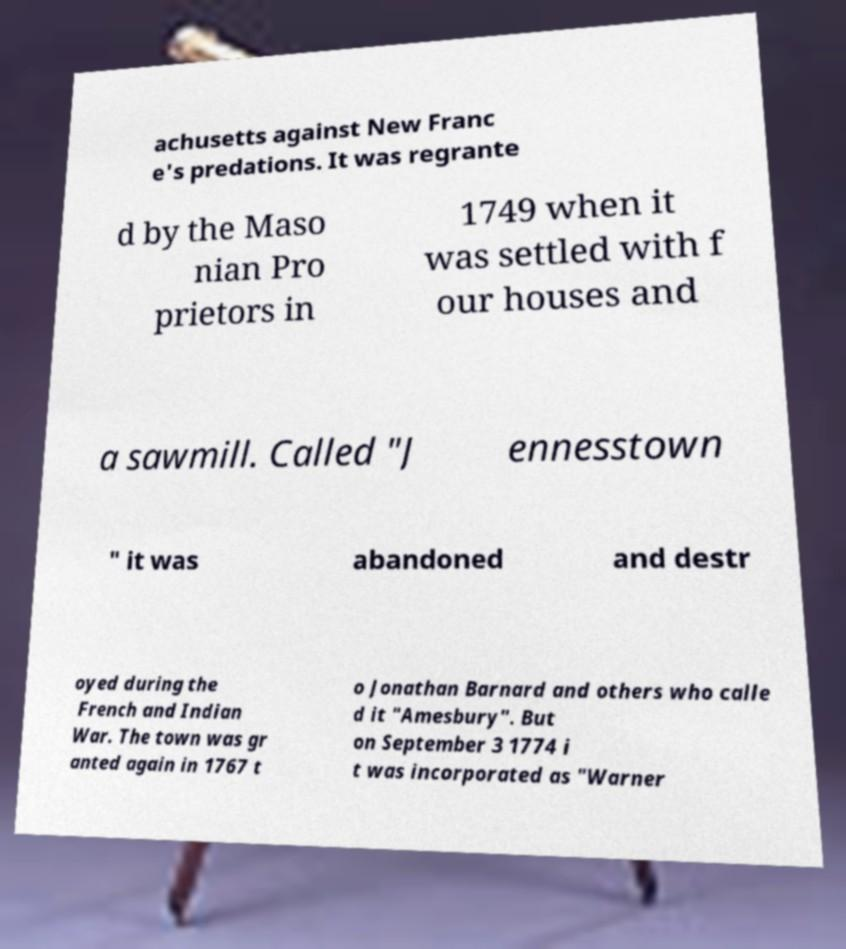Could you assist in decoding the text presented in this image and type it out clearly? achusetts against New Franc e's predations. It was regrante d by the Maso nian Pro prietors in 1749 when it was settled with f our houses and a sawmill. Called "J ennesstown " it was abandoned and destr oyed during the French and Indian War. The town was gr anted again in 1767 t o Jonathan Barnard and others who calle d it "Amesbury". But on September 3 1774 i t was incorporated as "Warner 